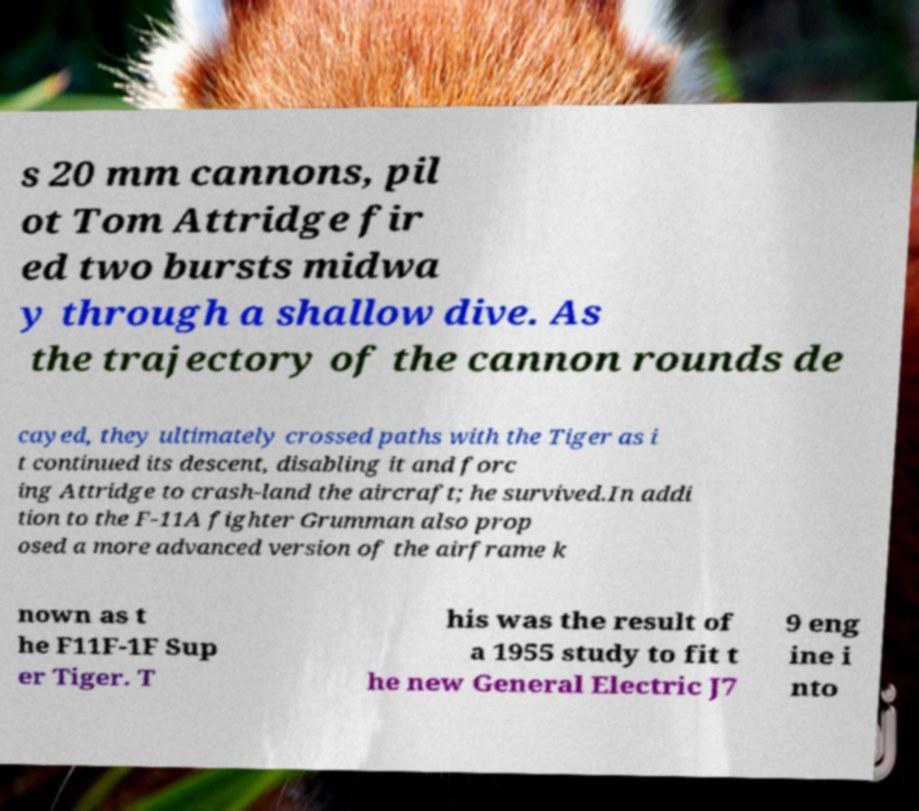Could you assist in decoding the text presented in this image and type it out clearly? s 20 mm cannons, pil ot Tom Attridge fir ed two bursts midwa y through a shallow dive. As the trajectory of the cannon rounds de cayed, they ultimately crossed paths with the Tiger as i t continued its descent, disabling it and forc ing Attridge to crash-land the aircraft; he survived.In addi tion to the F-11A fighter Grumman also prop osed a more advanced version of the airframe k nown as t he F11F-1F Sup er Tiger. T his was the result of a 1955 study to fit t he new General Electric J7 9 eng ine i nto 